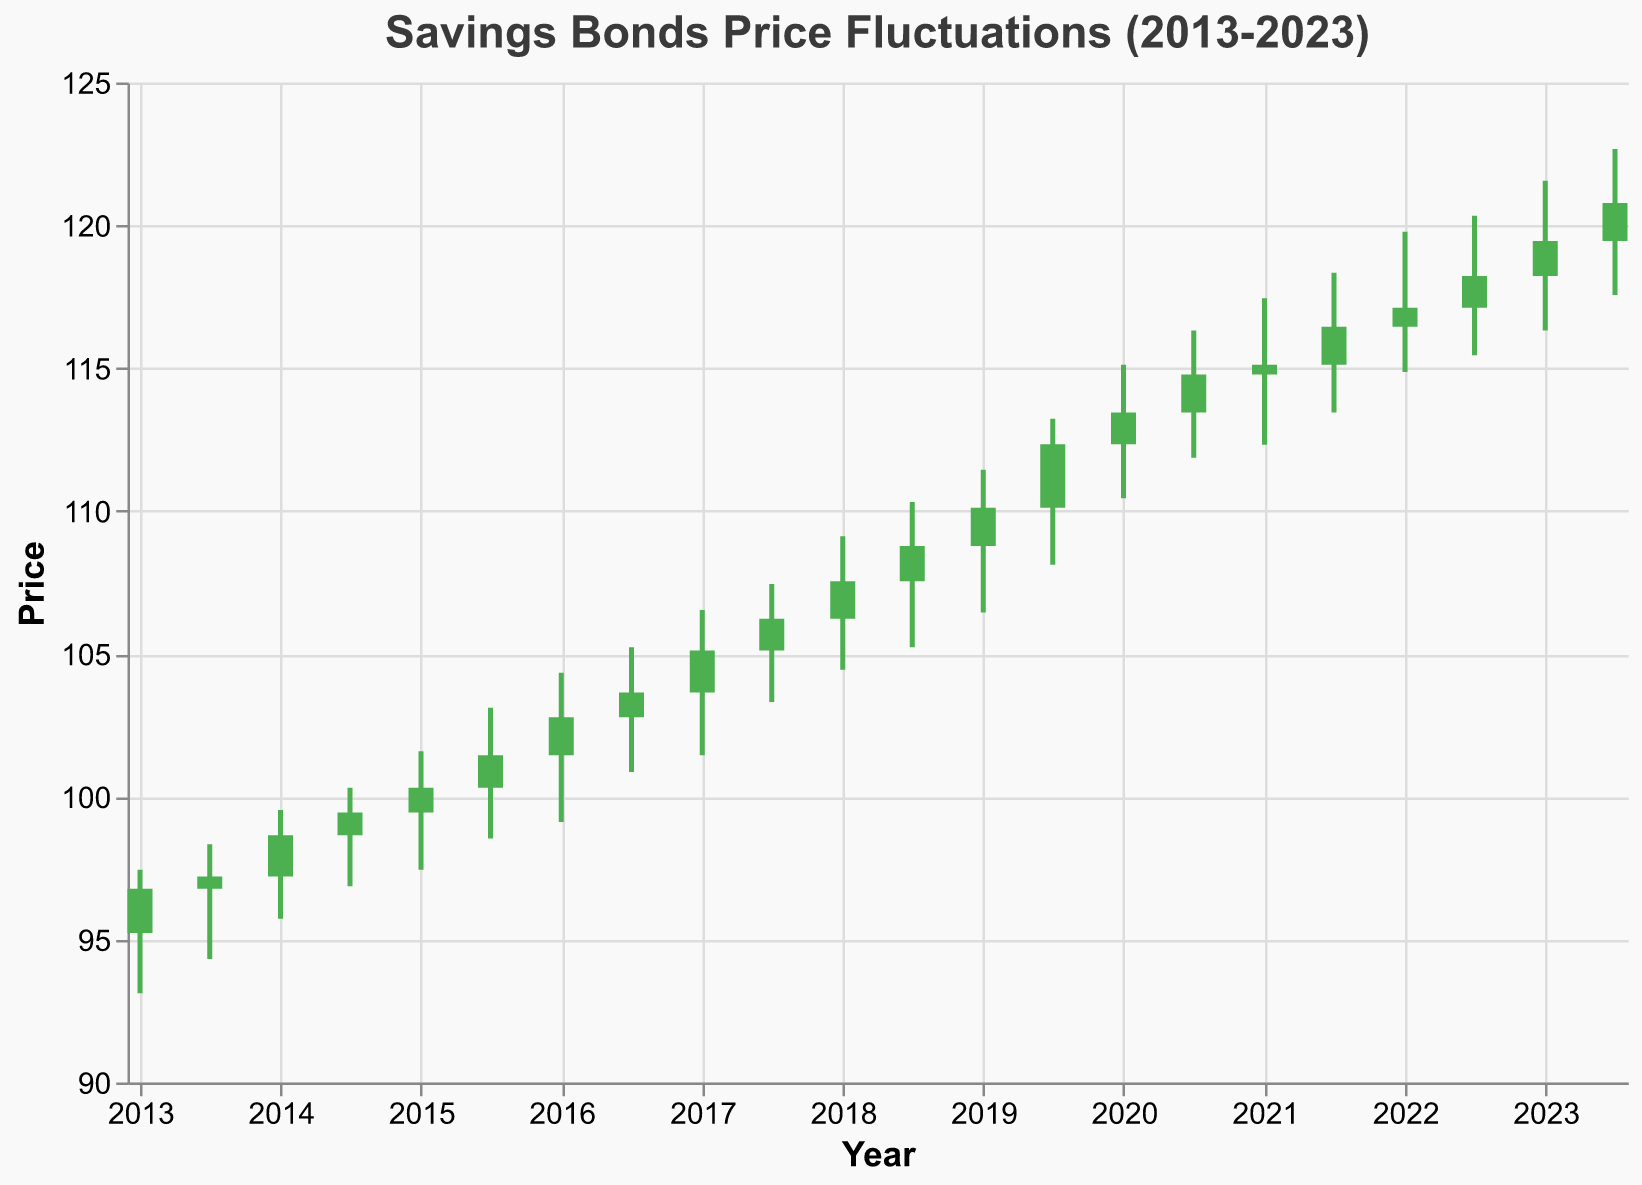How does the price trend of savings bonds change over the decade? To observe the trend, track the general movement of the close prices from 2013 to 2023. The closing prices start at 96.78 in 2013 and gradually rise, reaching 120.78 in mid-2023, indicating an upward trend over the decade.
Answer: Upward trend What is the highest and lowest price of the savings bonds within this period? The highest price is identified by the peak value in the High column, which occurs in mid-2023 at 122.67. The lowest price is found by the minimum value in the Low column, which occurs in early 2013 at 93.12.
Answer: Highest: 122.67, Lowest: 93.12 During which year did the closing price of savings bonds first reach above 100? Observe the closing prices and find the earliest year when the closing price is above 100. The closing price reaches 100.32 in early 2015.
Answer: 2015 How many times did the closing price decrease compared to the opening price? Check each data point where the closing price is lower than the opening price based on the colors (red for decrease, green for increase). The closing prices are lower than the opening prices in 5 instances.
Answer: 5 times What was the price change (difference) from 2015 to 2020? Compare the closing prices of early 2015 (100.32) and early 2020 (113.45). The difference is 113.45 - 100.32 = 13.13.
Answer: 13.13 Which year experienced the highest volatility in savings bonds prices? Notice the length of the candlesticks (difference between High and Low values) for each year. The longest candlestick indicates the highest volatility, which occurs in mid-2023 with a High of 122.67 and a Low of 117.56, a range of 5.11.
Answer: 2023 Was there any year where both the opening and closing prices of savings bonds were exactly the same? Inspect all the data points where Open equals Close. No such match exists within the given data.
Answer: No Which half-year period had the smallest range between the high and low prices? Calculate the range (High - Low) for each half-year period and find the smallest value. The smallest range is from early 2017 with a High of 106.54 and a Low of 101.45, a difference of 5.09.
Answer: Early 2017 Between 2018 and 2019, what was the increase in closing price? Take the closing price of early 2019 (110.12) and subtract the closing price of early 2018 (107.54). The increase is 110.12 - 107.54 = 2.58.
Answer: 2.58 